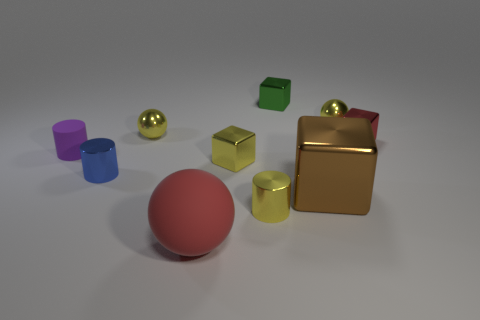Subtract all small metallic balls. How many balls are left? 1 Subtract all yellow cylinders. How many cylinders are left? 2 Subtract 1 cubes. How many cubes are left? 3 Subtract all cubes. How many objects are left? 6 Add 8 small blue cylinders. How many small blue cylinders exist? 9 Subtract 0 green spheres. How many objects are left? 10 Subtract all brown cubes. Subtract all gray balls. How many cubes are left? 3 Subtract all purple cylinders. How many yellow balls are left? 2 Subtract all yellow metallic objects. Subtract all big red things. How many objects are left? 5 Add 2 small red objects. How many small red objects are left? 3 